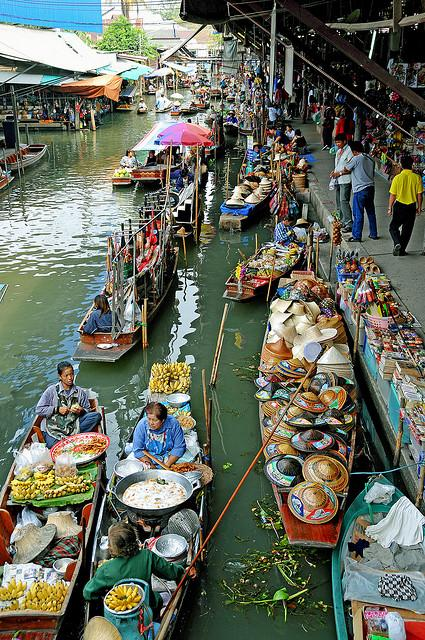What are on some of the boats? food 